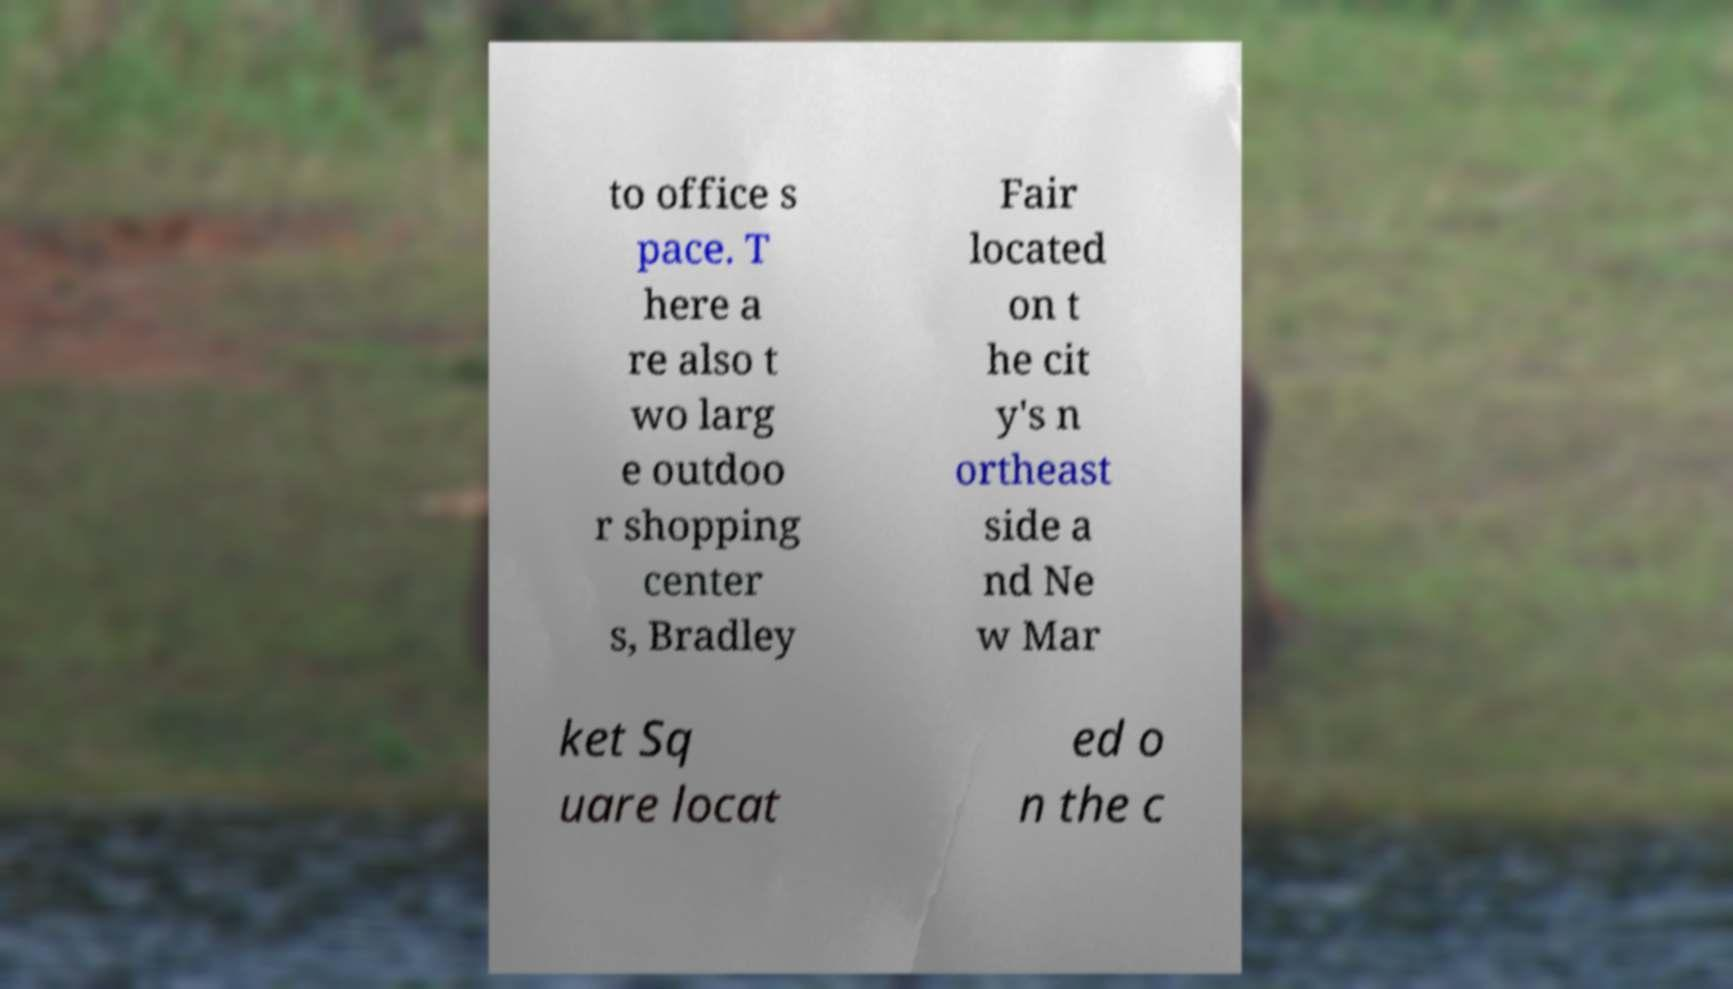What messages or text are displayed in this image? I need them in a readable, typed format. to office s pace. T here a re also t wo larg e outdoo r shopping center s, Bradley Fair located on t he cit y's n ortheast side a nd Ne w Mar ket Sq uare locat ed o n the c 